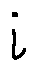Convert formula to latex. <formula><loc_0><loc_0><loc_500><loc_500>i</formula> 